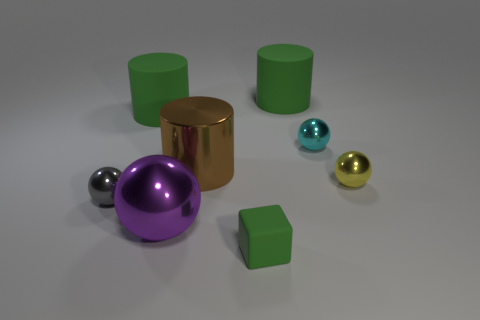Add 1 large green matte cylinders. How many objects exist? 9 Subtract all blocks. How many objects are left? 7 Add 7 small metallic things. How many small metallic things are left? 10 Add 1 gray cubes. How many gray cubes exist? 1 Subtract 1 green cubes. How many objects are left? 7 Subtract all large purple metallic things. Subtract all big green cylinders. How many objects are left? 5 